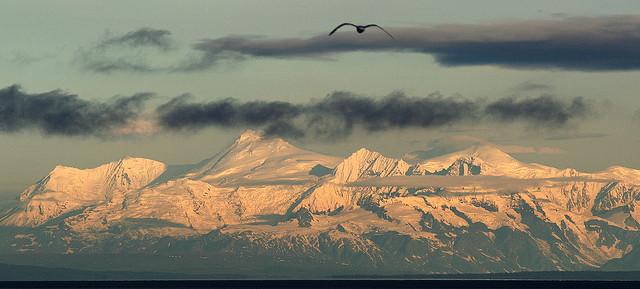How many mountains are in the background?
Quick response, please. 1. Are there mountains in the picture?
Give a very brief answer. Yes. Is there snow on the mountain?
Be succinct. Yes. Is the bird in the air?
Write a very short answer. Yes. What is the white scaly substance on the rocks?
Be succinct. Snow. 